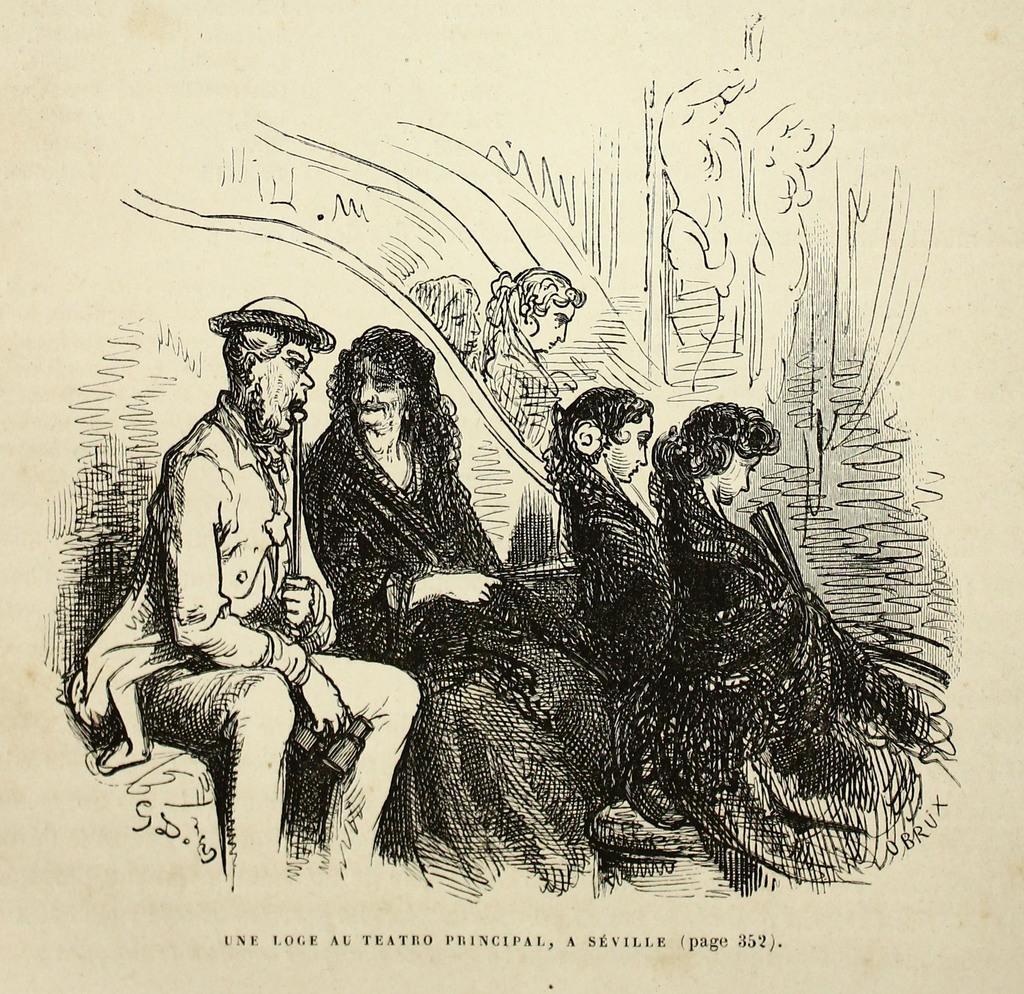How would you summarize this image in a sentence or two? This is the picture of a sketch. In this image we can see the people sitting. In the background we can see the people. At the bottom portion of the picture there is something written. 